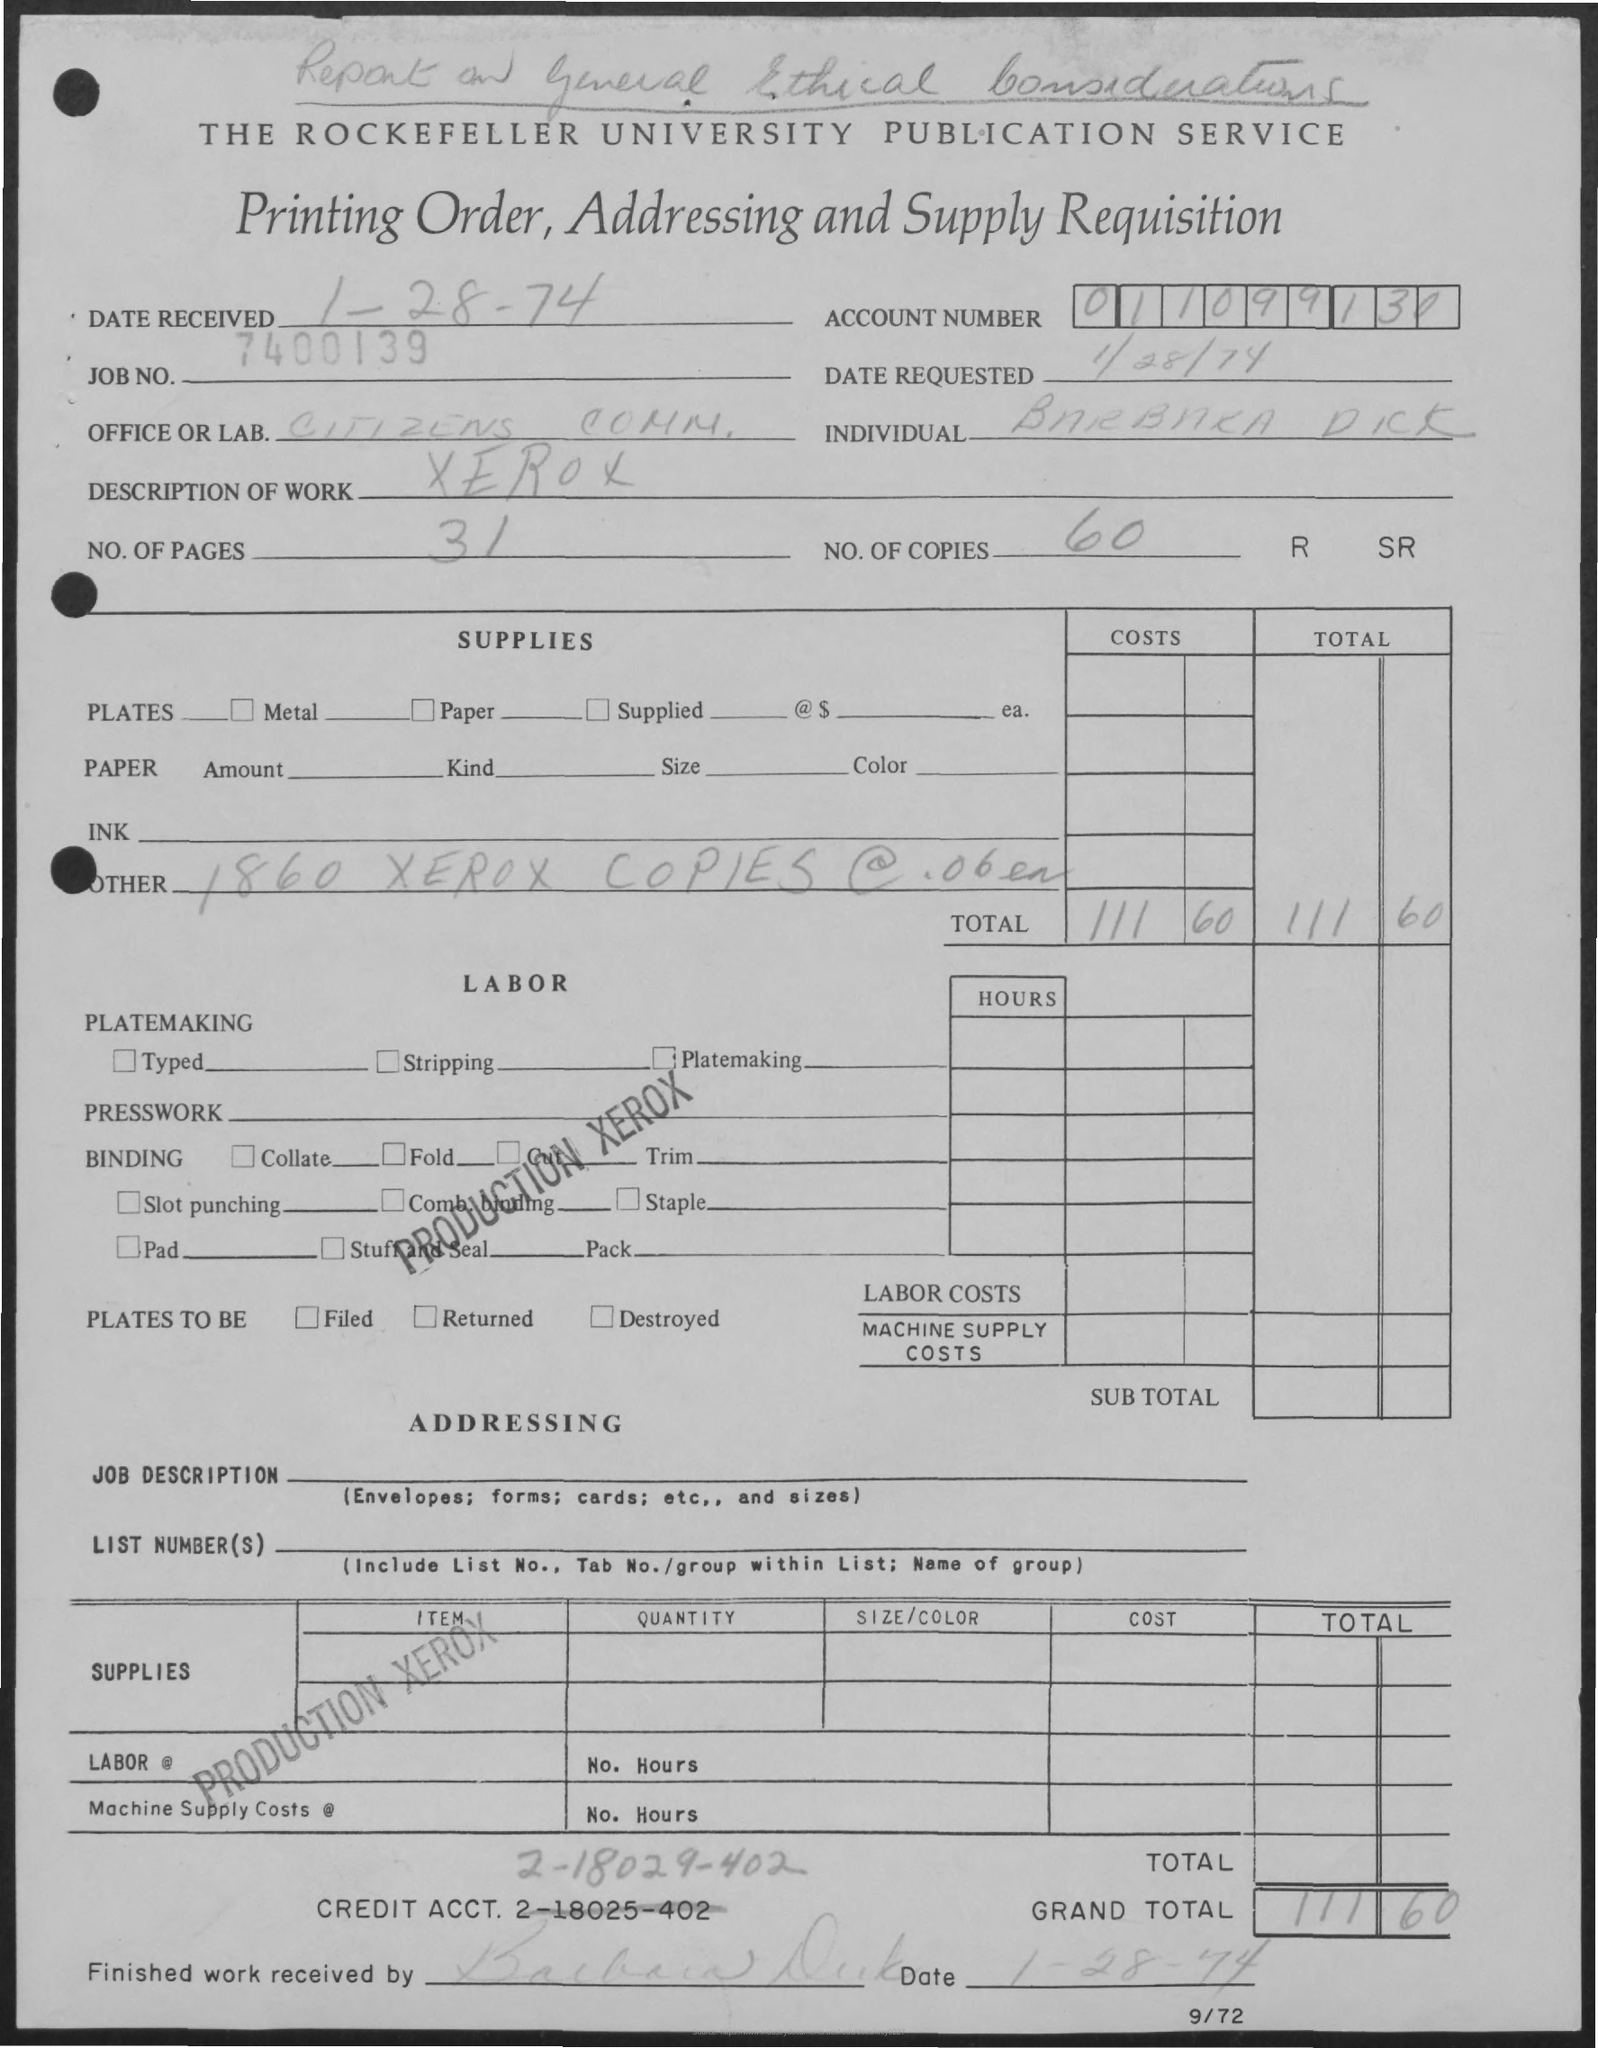What can you infer from the handwriting on the top of the document? The handwriting at the top of the document seems to refer to 'Report on General Ethical Considerations,' which might indicate that the document was used in the context of discussing ethical matters, likely linked to the work or research carried out by the office or lab mentioned. 